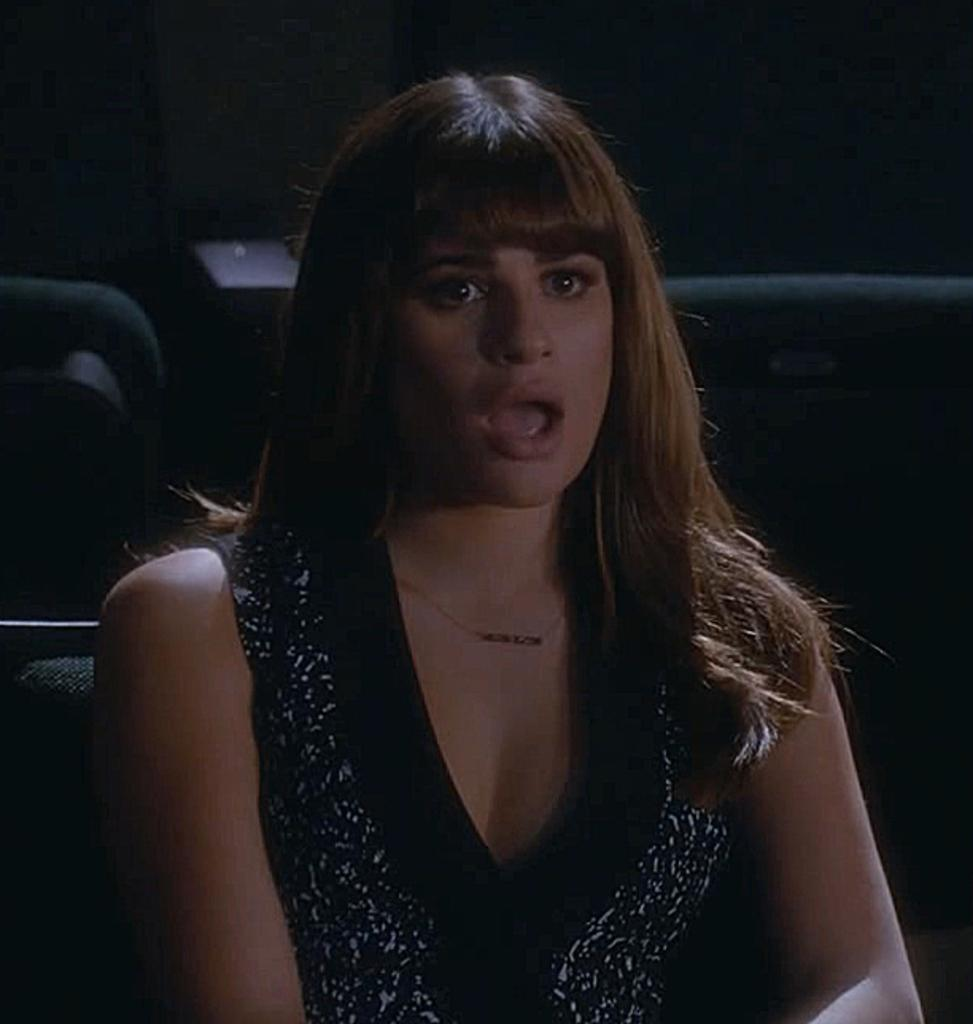Who is the main subject in the image? There is a woman in the image. What is the woman doing in the image? The woman is sitting on a chair. What can be observed about the background of the image? The background of the image is dark. What type of letter is the woman holding in the image? There is no letter present in the image; the woman is simply sitting on a chair. What is the woman using to copy the letter in the image? There is no letter or copying activity present in the image. 